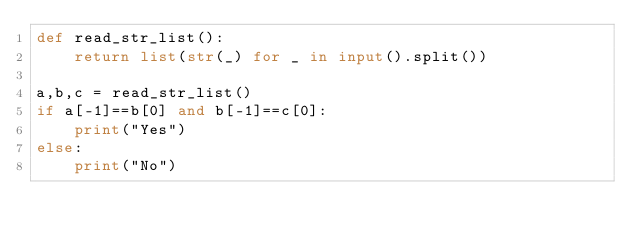Convert code to text. <code><loc_0><loc_0><loc_500><loc_500><_Python_>def read_str_list():
    return list(str(_) for _ in input().split())

a,b,c = read_str_list()
if a[-1]==b[0] and b[-1]==c[0]:
    print("Yes")
else:
    print("No")</code> 